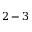Convert formula to latex. <formula><loc_0><loc_0><loc_500><loc_500>2 - 3</formula> 